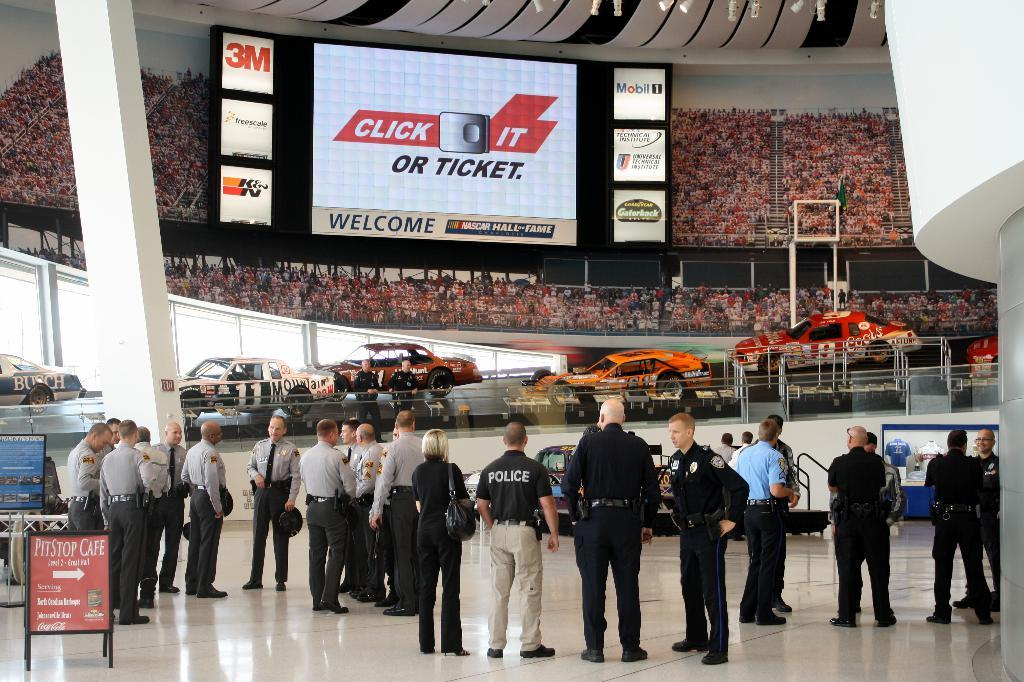What type of people can be seen in the image? There are policemen standing in the image. Where are the policemen positioned in the image? The policemen are standing on the floor. What can be seen happening in the background of the image? There are vehicles moving in the background of the image. What else can be seen in the background of the image? There are spectators and a projector screen in the background of the image. What type of frame is the stranger holding in the image? There is no stranger or frame present in the image. 